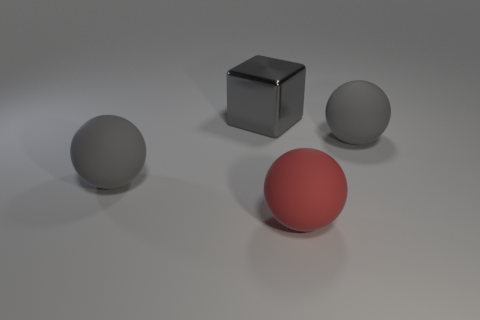Is there anything else that is the same shape as the large red matte object?
Provide a succinct answer. Yes. There is a rubber sphere that is to the left of the big block; does it have the same color as the big matte sphere that is right of the large red matte object?
Ensure brevity in your answer.  Yes. Is the number of big red spheres that are behind the large red matte thing less than the number of big things in front of the metallic block?
Your answer should be very brief. Yes. What shape is the red thing that is on the right side of the large gray metallic thing?
Your answer should be very brief. Sphere. How many other objects are there of the same material as the large gray block?
Provide a succinct answer. 0. Do the gray shiny thing and the big gray rubber thing to the right of the red object have the same shape?
Offer a very short reply. No. Is the number of big gray things right of the gray metal thing greater than the number of large cubes that are right of the red rubber ball?
Your answer should be very brief. Yes. What number of things are green objects or big gray cubes?
Keep it short and to the point. 1. How many other things are the same color as the shiny block?
Provide a short and direct response. 2. What is the shape of the red rubber thing that is the same size as the gray shiny thing?
Make the answer very short. Sphere. 